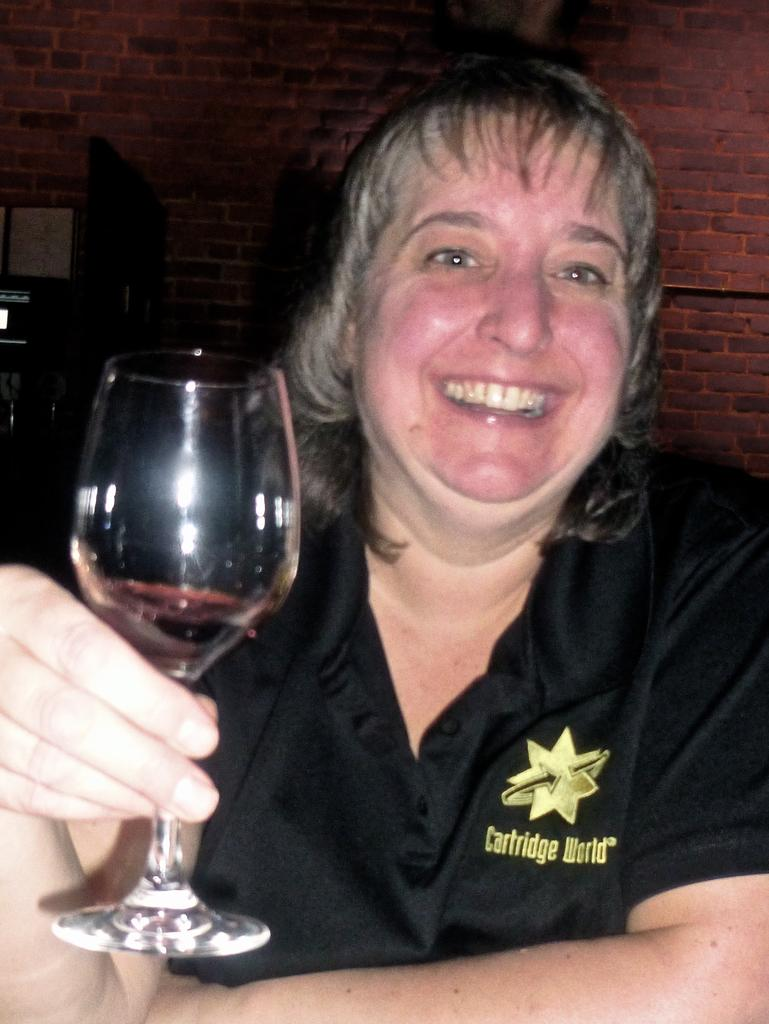Where was the image taken? The image is taken indoors. What can be seen in the background of the image? There is a wall in the background of the image. Who is the main subject in the image? There is a woman in the middle of the image. What is the woman's facial expression? The woman has a smiling face. What is the woman holding in her hand? The woman is holding a glass with wine in her hand. What type of experience is the police officer having in the image? There is no police officer present in the image, so it is not possible to determine their experience. 